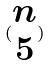<formula> <loc_0><loc_0><loc_500><loc_500>( \begin{matrix} n \\ 5 \end{matrix} )</formula> 